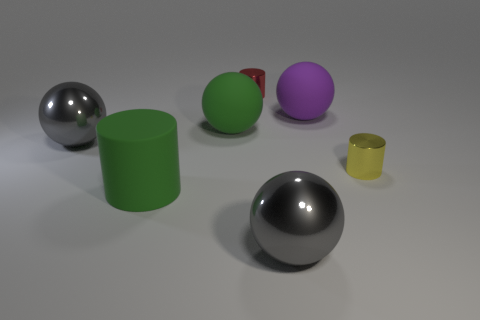Add 1 red matte cubes. How many objects exist? 8 Subtract all cylinders. How many objects are left? 4 Subtract all tiny things. Subtract all matte objects. How many objects are left? 2 Add 2 large purple balls. How many large purple balls are left? 3 Add 2 yellow shiny objects. How many yellow shiny objects exist? 3 Subtract 1 green cylinders. How many objects are left? 6 